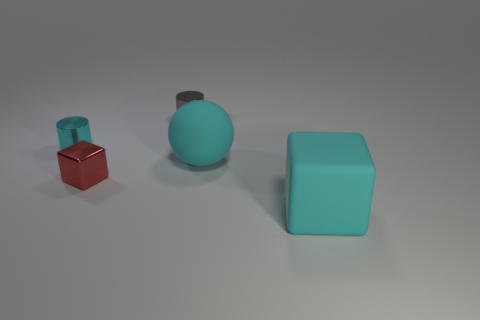Add 5 small brown matte cylinders. How many objects exist? 10 Subtract all cylinders. How many objects are left? 3 Subtract 0 gray cubes. How many objects are left? 5 Subtract all small brown rubber blocks. Subtract all large cyan things. How many objects are left? 3 Add 2 gray cylinders. How many gray cylinders are left? 3 Add 3 small blue matte blocks. How many small blue matte blocks exist? 3 